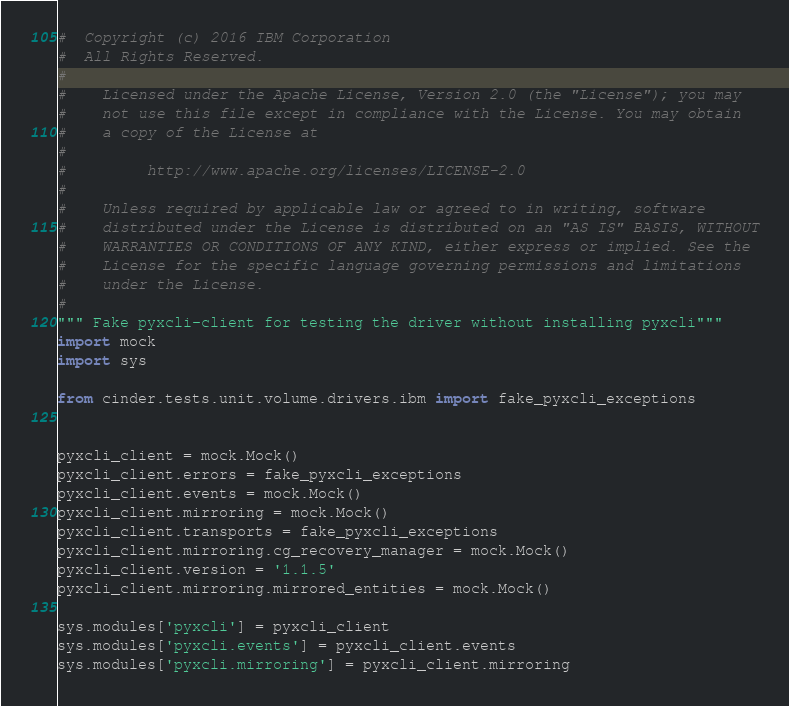Convert code to text. <code><loc_0><loc_0><loc_500><loc_500><_Python_>#  Copyright (c) 2016 IBM Corporation
#  All Rights Reserved.
#
#    Licensed under the Apache License, Version 2.0 (the "License"); you may
#    not use this file except in compliance with the License. You may obtain
#    a copy of the License at
#
#         http://www.apache.org/licenses/LICENSE-2.0
#
#    Unless required by applicable law or agreed to in writing, software
#    distributed under the License is distributed on an "AS IS" BASIS, WITHOUT
#    WARRANTIES OR CONDITIONS OF ANY KIND, either express or implied. See the
#    License for the specific language governing permissions and limitations
#    under the License.
#
""" Fake pyxcli-client for testing the driver without installing pyxcli"""
import mock
import sys

from cinder.tests.unit.volume.drivers.ibm import fake_pyxcli_exceptions


pyxcli_client = mock.Mock()
pyxcli_client.errors = fake_pyxcli_exceptions
pyxcli_client.events = mock.Mock()
pyxcli_client.mirroring = mock.Mock()
pyxcli_client.transports = fake_pyxcli_exceptions
pyxcli_client.mirroring.cg_recovery_manager = mock.Mock()
pyxcli_client.version = '1.1.5'
pyxcli_client.mirroring.mirrored_entities = mock.Mock()

sys.modules['pyxcli'] = pyxcli_client
sys.modules['pyxcli.events'] = pyxcli_client.events
sys.modules['pyxcli.mirroring'] = pyxcli_client.mirroring
</code> 